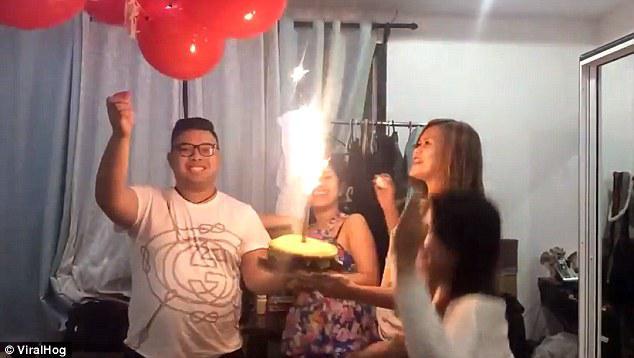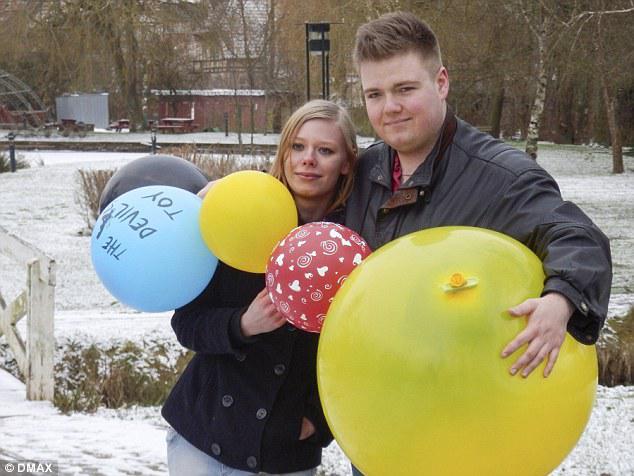The first image is the image on the left, the second image is the image on the right. Given the left and right images, does the statement "Someone is blowing up a balloon in the right image." hold true? Answer yes or no. No. The first image is the image on the left, the second image is the image on the right. Examine the images to the left and right. Is the description "There is at least one image with a man blowing up a yellow balloon." accurate? Answer yes or no. No. 